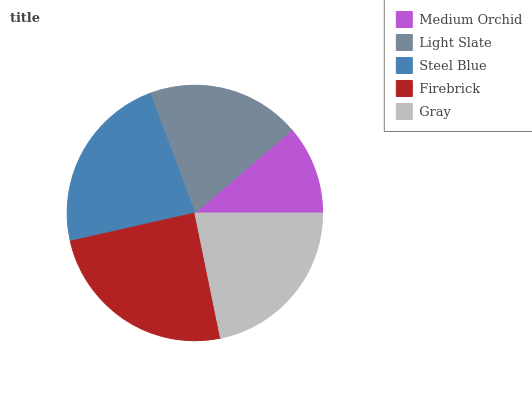Is Medium Orchid the minimum?
Answer yes or no. Yes. Is Firebrick the maximum?
Answer yes or no. Yes. Is Light Slate the minimum?
Answer yes or no. No. Is Light Slate the maximum?
Answer yes or no. No. Is Light Slate greater than Medium Orchid?
Answer yes or no. Yes. Is Medium Orchid less than Light Slate?
Answer yes or no. Yes. Is Medium Orchid greater than Light Slate?
Answer yes or no. No. Is Light Slate less than Medium Orchid?
Answer yes or no. No. Is Gray the high median?
Answer yes or no. Yes. Is Gray the low median?
Answer yes or no. Yes. Is Light Slate the high median?
Answer yes or no. No. Is Medium Orchid the low median?
Answer yes or no. No. 